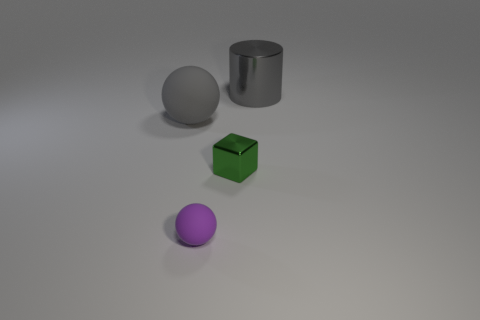Are there any other small green objects made of the same material as the green object?
Provide a succinct answer. No. How many rubber objects are behind the green shiny thing and in front of the tiny green thing?
Offer a terse response. 0. Is the number of tiny balls behind the large matte sphere less than the number of big gray matte things on the right side of the small green metal object?
Keep it short and to the point. No. Do the small shiny thing and the tiny purple thing have the same shape?
Your answer should be compact. No. How many other things are there of the same size as the cylinder?
Provide a succinct answer. 1. What number of things are either spheres that are in front of the big gray matte sphere or shiny objects behind the big gray matte thing?
Your answer should be very brief. 2. How many other metal things have the same shape as the tiny green object?
Offer a terse response. 0. There is a thing that is in front of the big matte ball and behind the purple rubber sphere; what material is it?
Keep it short and to the point. Metal. There is a purple rubber thing; what number of gray things are on the left side of it?
Give a very brief answer. 1. What number of big shiny cylinders are there?
Offer a terse response. 1. 